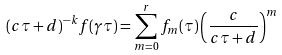<formula> <loc_0><loc_0><loc_500><loc_500>( c \tau + d ) ^ { - k } f ( \gamma \tau ) = \sum _ { m = 0 } ^ { r } f _ { m } ( \tau ) \left ( \frac { c } { c \tau + d } \right ) ^ { m }</formula> 